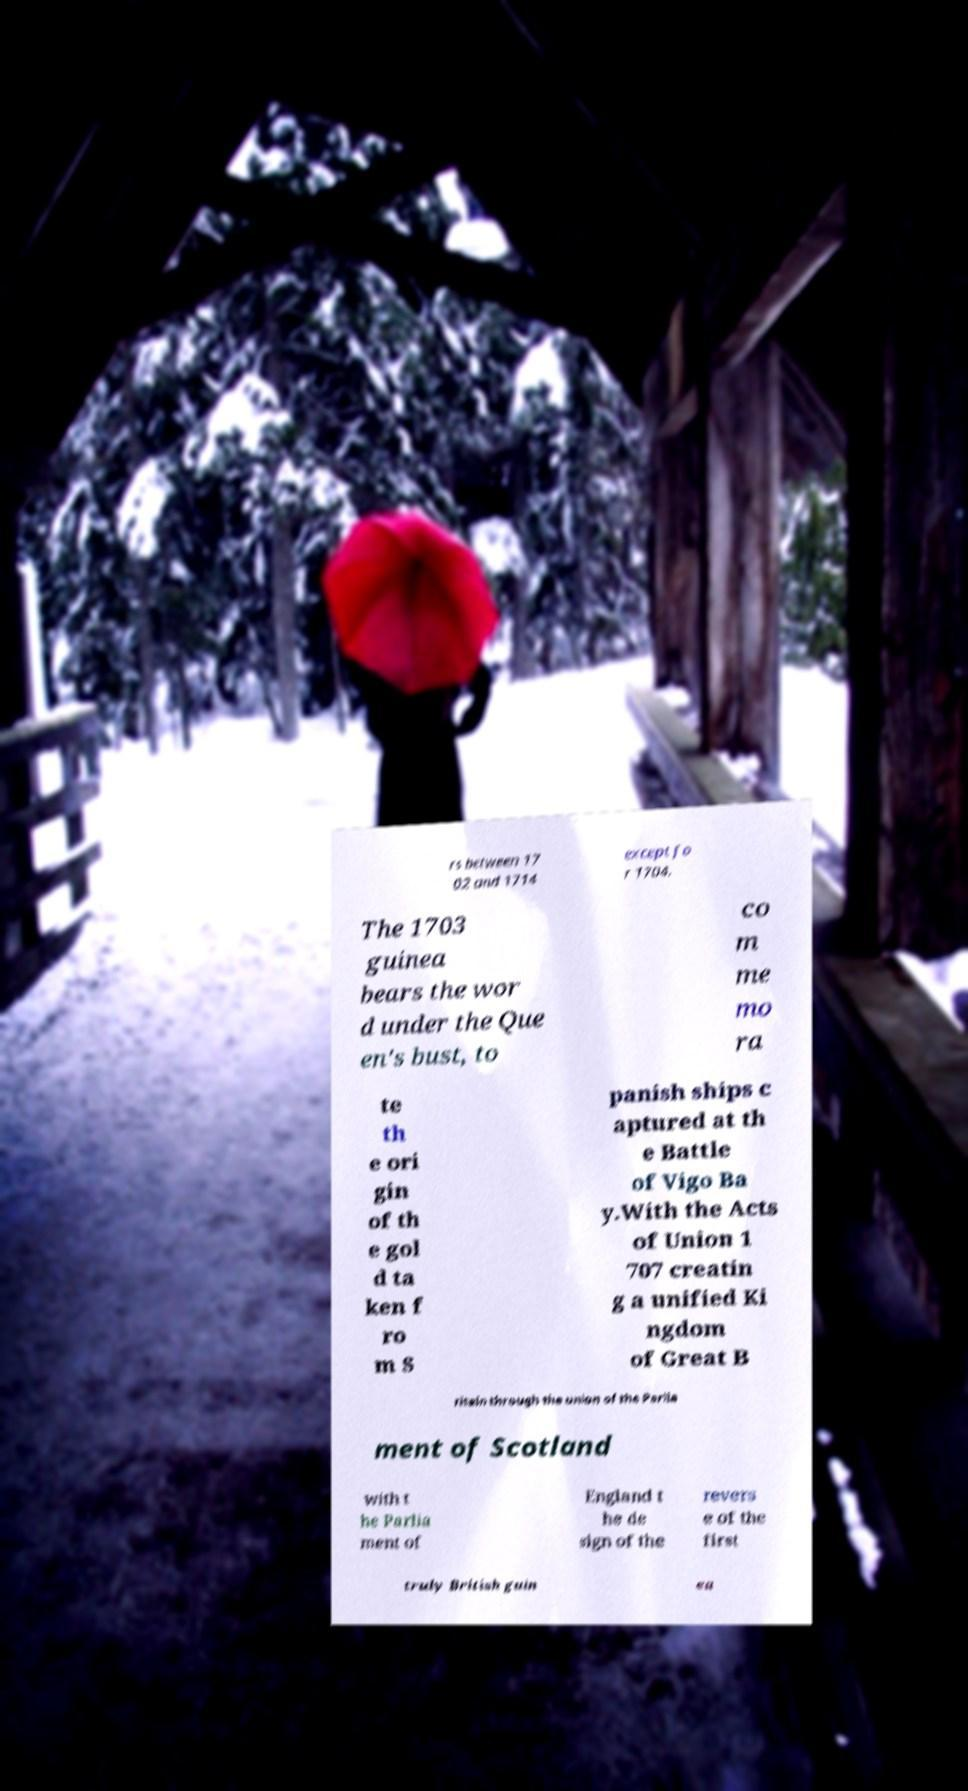I need the written content from this picture converted into text. Can you do that? rs between 17 02 and 1714 except fo r 1704. The 1703 guinea bears the wor d under the Que en's bust, to co m me mo ra te th e ori gin of th e gol d ta ken f ro m S panish ships c aptured at th e Battle of Vigo Ba y.With the Acts of Union 1 707 creatin g a unified Ki ngdom of Great B ritain through the union of the Parlia ment of Scotland with t he Parlia ment of England t he de sign of the revers e of the first truly British guin ea 